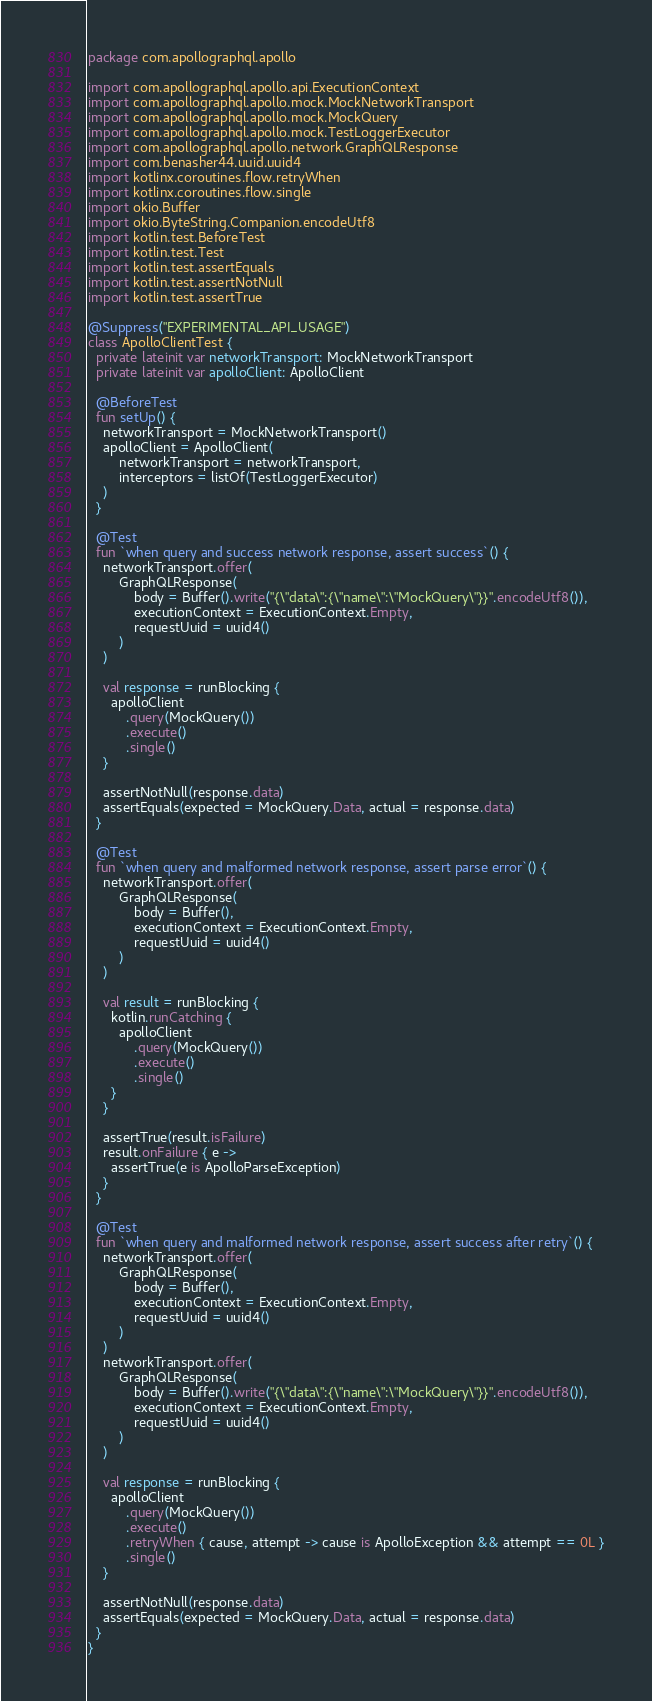<code> <loc_0><loc_0><loc_500><loc_500><_Kotlin_>package com.apollographql.apollo

import com.apollographql.apollo.api.ExecutionContext
import com.apollographql.apollo.mock.MockNetworkTransport
import com.apollographql.apollo.mock.MockQuery
import com.apollographql.apollo.mock.TestLoggerExecutor
import com.apollographql.apollo.network.GraphQLResponse
import com.benasher44.uuid.uuid4
import kotlinx.coroutines.flow.retryWhen
import kotlinx.coroutines.flow.single
import okio.Buffer
import okio.ByteString.Companion.encodeUtf8
import kotlin.test.BeforeTest
import kotlin.test.Test
import kotlin.test.assertEquals
import kotlin.test.assertNotNull
import kotlin.test.assertTrue

@Suppress("EXPERIMENTAL_API_USAGE")
class ApolloClientTest {
  private lateinit var networkTransport: MockNetworkTransport
  private lateinit var apolloClient: ApolloClient

  @BeforeTest
  fun setUp() {
    networkTransport = MockNetworkTransport()
    apolloClient = ApolloClient(
        networkTransport = networkTransport,
        interceptors = listOf(TestLoggerExecutor)
    )
  }

  @Test
  fun `when query and success network response, assert success`() {
    networkTransport.offer(
        GraphQLResponse(
            body = Buffer().write("{\"data\":{\"name\":\"MockQuery\"}}".encodeUtf8()),
            executionContext = ExecutionContext.Empty,
            requestUuid = uuid4()
        )
    )

    val response = runBlocking {
      apolloClient
          .query(MockQuery())
          .execute()
          .single()
    }

    assertNotNull(response.data)
    assertEquals(expected = MockQuery.Data, actual = response.data)
  }

  @Test
  fun `when query and malformed network response, assert parse error`() {
    networkTransport.offer(
        GraphQLResponse(
            body = Buffer(),
            executionContext = ExecutionContext.Empty,
            requestUuid = uuid4()
        )
    )

    val result = runBlocking {
      kotlin.runCatching {
        apolloClient
            .query(MockQuery())
            .execute()
            .single()
      }
    }

    assertTrue(result.isFailure)
    result.onFailure { e ->
      assertTrue(e is ApolloParseException)
    }
  }

  @Test
  fun `when query and malformed network response, assert success after retry`() {
    networkTransport.offer(
        GraphQLResponse(
            body = Buffer(),
            executionContext = ExecutionContext.Empty,
            requestUuid = uuid4()
        )
    )
    networkTransport.offer(
        GraphQLResponse(
            body = Buffer().write("{\"data\":{\"name\":\"MockQuery\"}}".encodeUtf8()),
            executionContext = ExecutionContext.Empty,
            requestUuid = uuid4()
        )
    )

    val response = runBlocking {
      apolloClient
          .query(MockQuery())
          .execute()
          .retryWhen { cause, attempt -> cause is ApolloException && attempt == 0L }
          .single()
    }

    assertNotNull(response.data)
    assertEquals(expected = MockQuery.Data, actual = response.data)
  }
}
</code> 